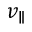<formula> <loc_0><loc_0><loc_500><loc_500>v _ { \| }</formula> 